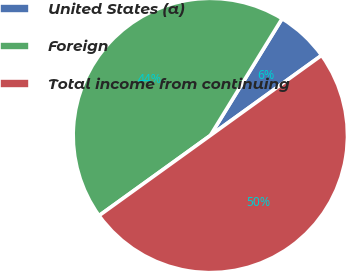Convert chart. <chart><loc_0><loc_0><loc_500><loc_500><pie_chart><fcel>United States (a)<fcel>Foreign<fcel>Total income from continuing<nl><fcel>6.3%<fcel>43.7%<fcel>50.0%<nl></chart> 